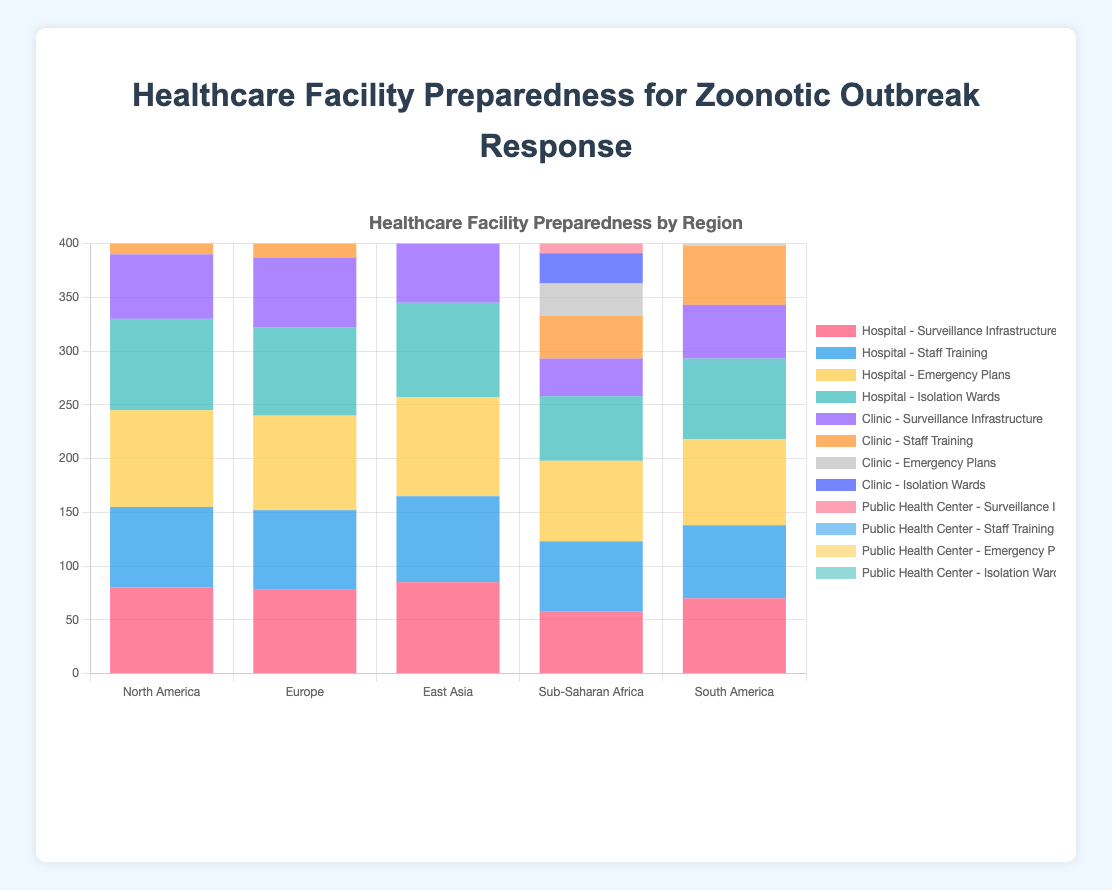Which region has the highest overall preparedness for hospitals in terms of Surveillance Infrastructure? By looking at the height of the red bars (representing Surveillance Infrastructure) for hospitals in each region, we can see that East Asia has the highest bar.
Answer: East Asia In which region do clinics have the least preparedness for Isolation Wards? By observing the purple bars (representing Isolation Wards) for clinics across the regions, Sub-Saharan Africa has the lowest bar.
Answer: Sub-Saharan Africa What is the combined preparedness score for Staff Training across all facility types in Europe? Add the blue bars (Hospitals: 74) + orange bars (Clinics: 68) + light blue bars (Public Health Centers: 76) for Europe: 74 + 68 + 76 = 218.
Answer: 218 How does the preparedness for Emergency Plans in hospitals compare between North America and South America? Compare the heights of the yellow bars for hospitals in North America and South America. North America's bar is higher (90) compared to South America's (80).
Answer: North America is higher What is the average preparedness score for Isolation Wards in clinics across all regions? Add the purple bars for clinics in all regions (45 + 48 + 50 + 28 + 42) and divide by the number of regions (5): (45 + 48 + 50 + 28 + 42) / 5 = 42.6.
Answer: 42.6 